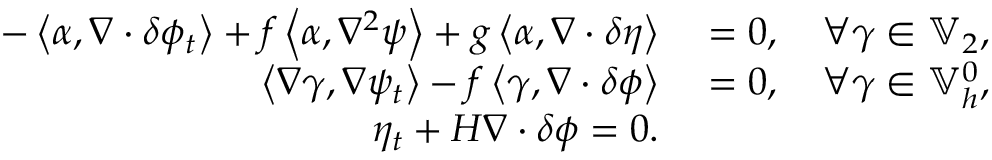Convert formula to latex. <formula><loc_0><loc_0><loc_500><loc_500>\begin{array} { r l } { - \left \langle \alpha , \nabla \cdot \delta \phi _ { t } \right \rangle + f \left \langle \alpha , \nabla ^ { 2 } \psi \right \rangle + g \left \langle \alpha , \nabla \cdot \delta \eta \right \rangle } & = 0 , \quad \forall \gamma \in \mathbb { V } _ { 2 } , } \\ { \left \langle \nabla \gamma , \nabla \psi _ { t } \right \rangle - f \left \langle \gamma , \nabla \cdot \delta \phi \right \rangle } & = 0 , \quad \forall \gamma \in \mathbb { V } _ { h } ^ { 0 } , } \\ { \eta _ { t } + H \nabla \cdot \delta \phi = 0 . } \end{array}</formula> 